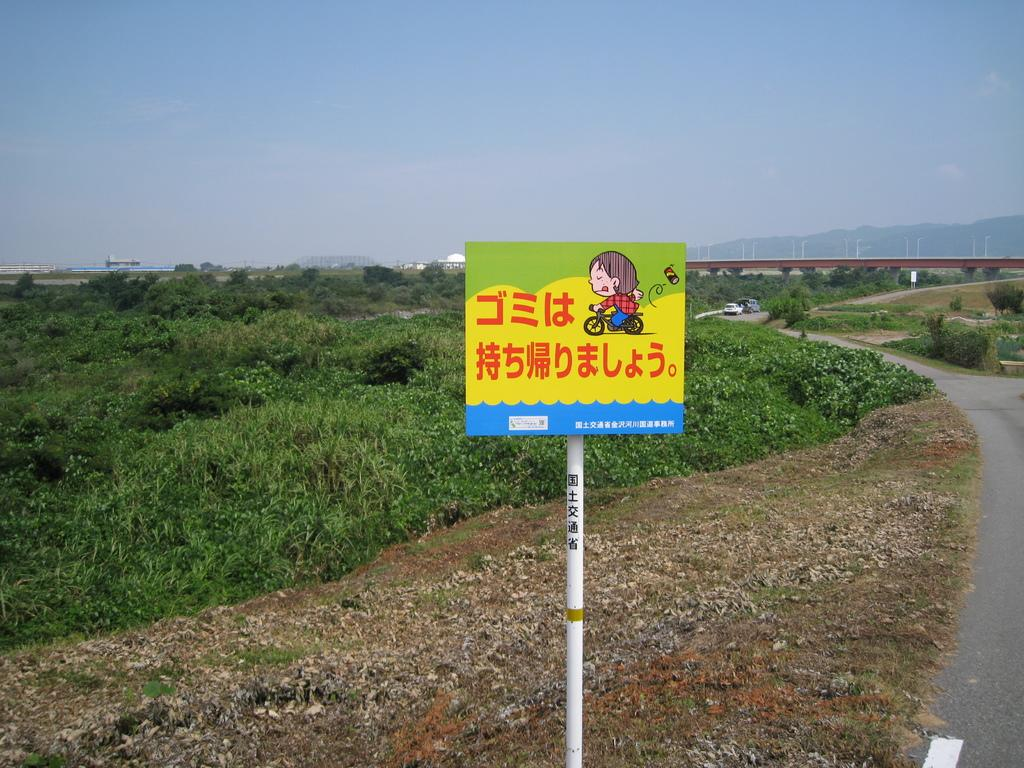What type of pathway is visible in the image? There is a road in the image. What type of vegetation can be seen in the image? There is grass in the image. What structure is present in the image that allows people or vehicles to cross over a body of water? There is a bridge in the image. What type of structure is visible in the image that might be used for living or working? There is a building in the image. What type of natural landform can be seen in the image? There is a mountain in the image. What type of sports equipment is visible in the image? There is a ski in the image. What type of vertical structure is visible in the image? There is a pole in the image. What type of flat, rigid surface is visible in the image? There is a board in the image. Where is the store located in the image? There is no store present in the image. What type of hat is the bean wearing in the image? There is no bean or hat present in the image. 